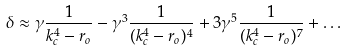Convert formula to latex. <formula><loc_0><loc_0><loc_500><loc_500>\delta \approx \gamma \frac { 1 } { k _ { c } ^ { 4 } - r _ { o } } - \gamma ^ { 3 } \frac { 1 } { ( k _ { c } ^ { 4 } - r _ { o } ) ^ { 4 } } + 3 \gamma ^ { 5 } \frac { 1 } { ( k _ { c } ^ { 4 } - r _ { o } ) ^ { 7 } } + \dots</formula> 